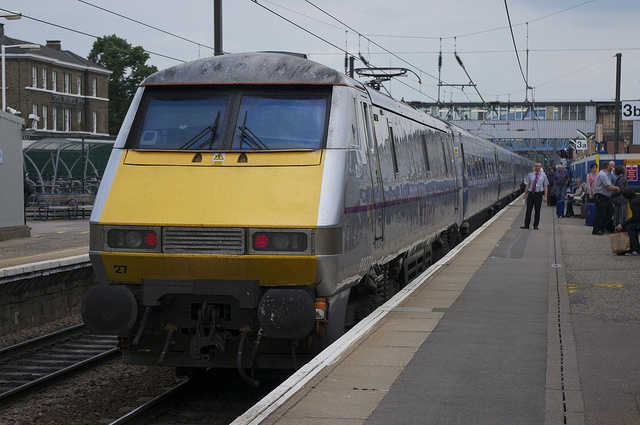Describe the objects in this image and their specific colors. I can see train in darkgray, black, gray, and tan tones, bench in darkgray, gray, and black tones, people in darkgray, black, and gray tones, people in darkgray, black, and gray tones, and people in darkgray, black, gray, and maroon tones in this image. 